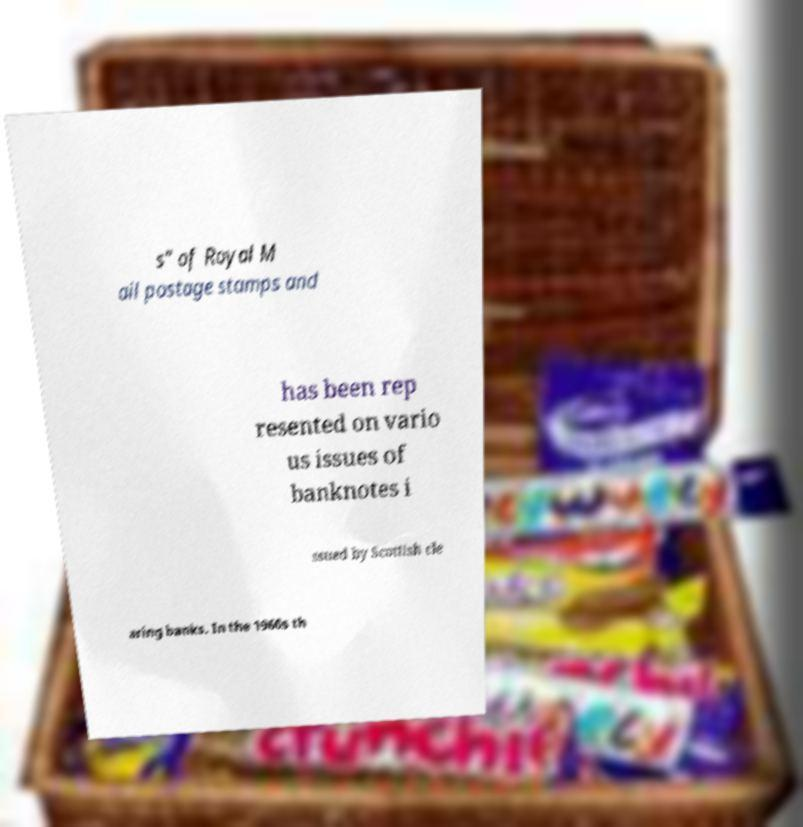Can you accurately transcribe the text from the provided image for me? s" of Royal M ail postage stamps and has been rep resented on vario us issues of banknotes i ssued by Scottish cle aring banks. In the 1960s th 